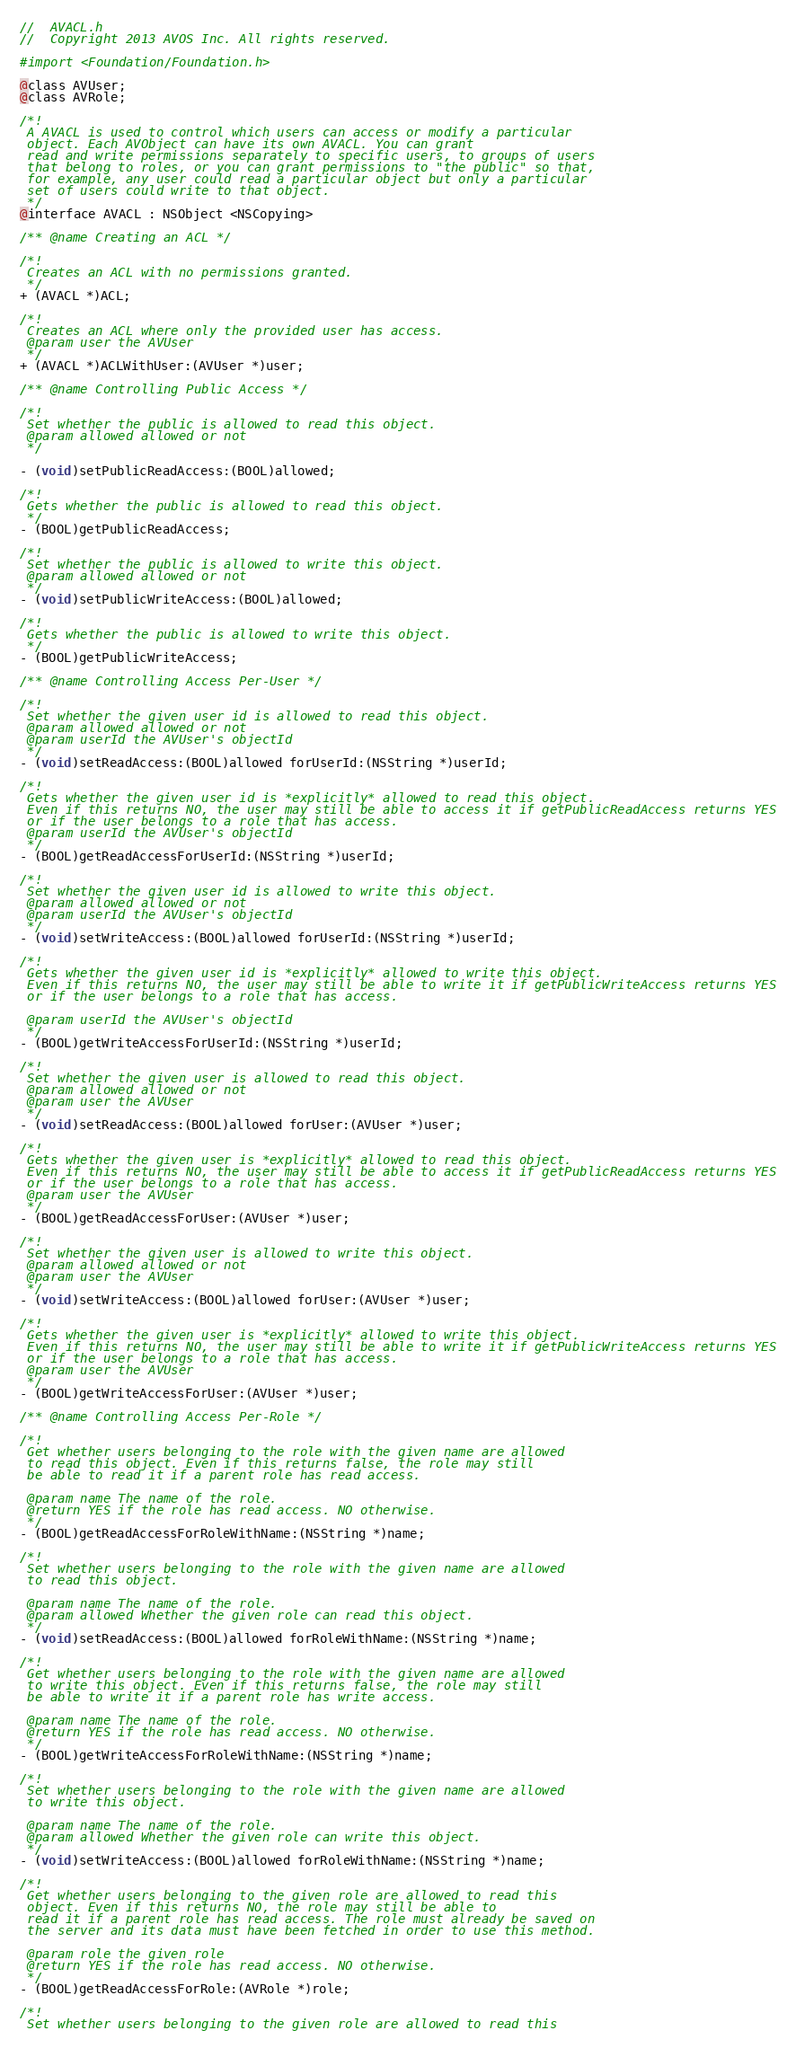Convert code to text. <code><loc_0><loc_0><loc_500><loc_500><_C_>//  AVACL.h
//  Copyright 2013 AVOS Inc. All rights reserved.

#import <Foundation/Foundation.h>

@class AVUser;
@class AVRole;

/*!
 A AVACL is used to control which users can access or modify a particular
 object. Each AVObject can have its own AVACL. You can grant
 read and write permissions separately to specific users, to groups of users
 that belong to roles, or you can grant permissions to "the public" so that,
 for example, any user could read a particular object but only a particular
 set of users could write to that object.
 */
@interface AVACL : NSObject <NSCopying> 

/** @name Creating an ACL */

/*!
 Creates an ACL with no permissions granted.
 */
+ (AVACL *)ACL;

/*!
 Creates an ACL where only the provided user has access.
 @param user the AVUser
 */
+ (AVACL *)ACLWithUser:(AVUser *)user;

/** @name Controlling Public Access */

/*!
 Set whether the public is allowed to read this object.
 @param allowed allowed or not
 */

- (void)setPublicReadAccess:(BOOL)allowed;

/*!
 Gets whether the public is allowed to read this object.
 */
- (BOOL)getPublicReadAccess;

/*!
 Set whether the public is allowed to write this object.
 @param allowed allowed or not
 */
- (void)setPublicWriteAccess:(BOOL)allowed;

/*!
 Gets whether the public is allowed to write this object.
 */
- (BOOL)getPublicWriteAccess;

/** @name Controlling Access Per-User */

/*!
 Set whether the given user id is allowed to read this object.
 @param allowed allowed or not
 @param userId the AVUser's objectId
 */
- (void)setReadAccess:(BOOL)allowed forUserId:(NSString *)userId;

/*!
 Gets whether the given user id is *explicitly* allowed to read this object.
 Even if this returns NO, the user may still be able to access it if getPublicReadAccess returns YES
 or if the user belongs to a role that has access.
 @param userId the AVUser's objectId
 */
- (BOOL)getReadAccessForUserId:(NSString *)userId;

/*!
 Set whether the given user id is allowed to write this object.
 @param allowed allowed or not
 @param userId the AVUser's objectId
 */
- (void)setWriteAccess:(BOOL)allowed forUserId:(NSString *)userId;

/*!
 Gets whether the given user id is *explicitly* allowed to write this object.
 Even if this returns NO, the user may still be able to write it if getPublicWriteAccess returns YES
 or if the user belongs to a role that has access.
 
 @param userId the AVUser's objectId
 */
- (BOOL)getWriteAccessForUserId:(NSString *)userId;

/*!
 Set whether the given user is allowed to read this object.
 @param allowed allowed or not
 @param user the AVUser
 */
- (void)setReadAccess:(BOOL)allowed forUser:(AVUser *)user;

/*!
 Gets whether the given user is *explicitly* allowed to read this object.
 Even if this returns NO, the user may still be able to access it if getPublicReadAccess returns YES
 or if the user belongs to a role that has access.
 @param user the AVUser
 */
- (BOOL)getReadAccessForUser:(AVUser *)user;

/*!
 Set whether the given user is allowed to write this object.
 @param allowed allowed or not
 @param user the AVUser
 */
- (void)setWriteAccess:(BOOL)allowed forUser:(AVUser *)user;

/*!
 Gets whether the given user is *explicitly* allowed to write this object.
 Even if this returns NO, the user may still be able to write it if getPublicWriteAccess returns YES
 or if the user belongs to a role that has access.
 @param user the AVUser
 */
- (BOOL)getWriteAccessForUser:(AVUser *)user;

/** @name Controlling Access Per-Role */

/*!
 Get whether users belonging to the role with the given name are allowed
 to read this object. Even if this returns false, the role may still
 be able to read it if a parent role has read access.
 
 @param name The name of the role.
 @return YES if the role has read access. NO otherwise.
 */
- (BOOL)getReadAccessForRoleWithName:(NSString *)name;

/*!
 Set whether users belonging to the role with the given name are allowed
 to read this object.
 
 @param name The name of the role.
 @param allowed Whether the given role can read this object.
 */
- (void)setReadAccess:(BOOL)allowed forRoleWithName:(NSString *)name;

/*!
 Get whether users belonging to the role with the given name are allowed
 to write this object. Even if this returns false, the role may still
 be able to write it if a parent role has write access.
 
 @param name The name of the role.
 @return YES if the role has read access. NO otherwise.
 */
- (BOOL)getWriteAccessForRoleWithName:(NSString *)name;

/*!
 Set whether users belonging to the role with the given name are allowed
 to write this object.
 
 @param name The name of the role.
 @param allowed Whether the given role can write this object.
 */
- (void)setWriteAccess:(BOOL)allowed forRoleWithName:(NSString *)name;

/*!
 Get whether users belonging to the given role are allowed to read this
 object. Even if this returns NO, the role may still be able to
 read it if a parent role has read access. The role must already be saved on
 the server and its data must have been fetched in order to use this method.
 
 @param role the given role
 @return YES if the role has read access. NO otherwise.
 */
- (BOOL)getReadAccessForRole:(AVRole *)role;

/*!
 Set whether users belonging to the given role are allowed to read this</code> 